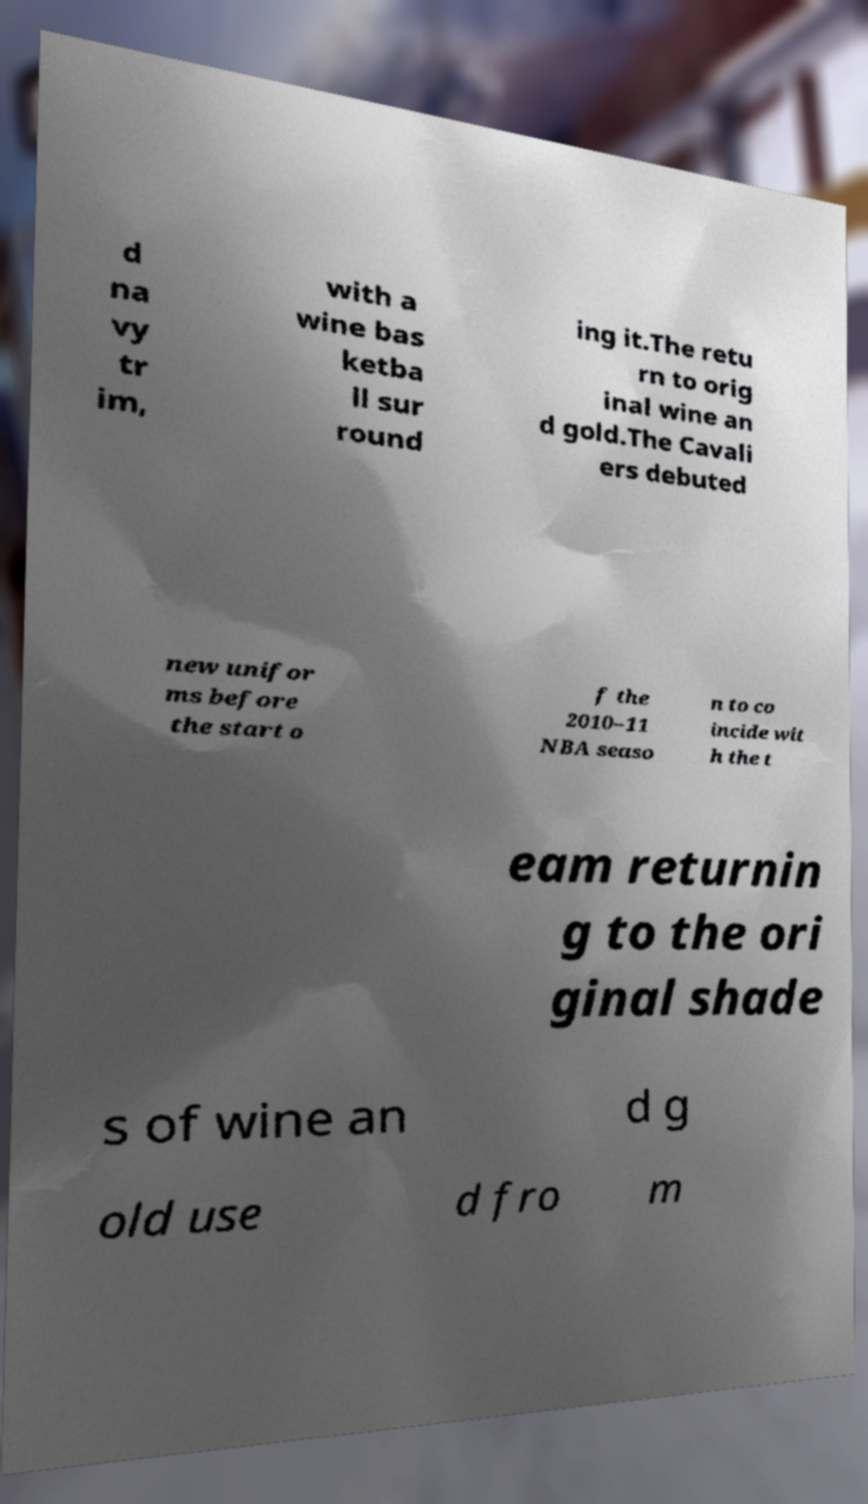Can you read and provide the text displayed in the image?This photo seems to have some interesting text. Can you extract and type it out for me? d na vy tr im, with a wine bas ketba ll sur round ing it.The retu rn to orig inal wine an d gold.The Cavali ers debuted new unifor ms before the start o f the 2010–11 NBA seaso n to co incide wit h the t eam returnin g to the ori ginal shade s of wine an d g old use d fro m 